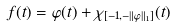Convert formula to latex. <formula><loc_0><loc_0><loc_500><loc_500>f ( t ) = \varphi ( t ) + \chi _ { [ - 1 , - \| \varphi \| _ { 1 } ] } ( t )</formula> 